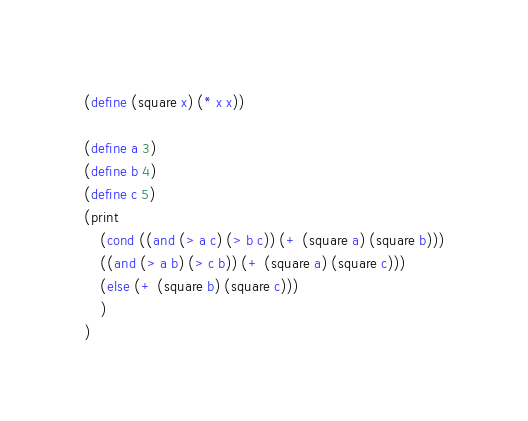<code> <loc_0><loc_0><loc_500><loc_500><_Scheme_>(define (square x) (* x x))

(define a 3)
(define b 4)
(define c 5)
(print
    (cond ((and (> a c) (> b c)) (+ (square a) (square b)))
	((and (> a b) (> c b)) (+ (square a) (square c)))
	(else (+ (square b) (square c)))
    )
)
</code> 